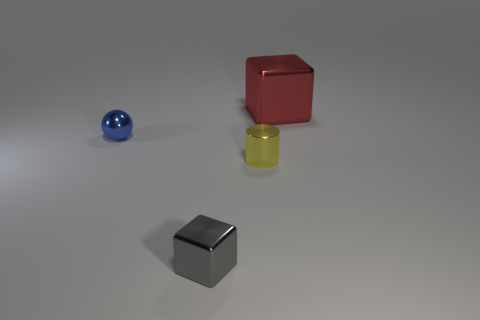Subtract all green blocks. Subtract all purple cylinders. How many blocks are left? 2 Add 1 large red metal blocks. How many objects exist? 5 Subtract all spheres. How many objects are left? 3 Add 2 gray metal blocks. How many gray metal blocks are left? 3 Add 4 small yellow metallic things. How many small yellow metallic things exist? 5 Subtract 0 brown cylinders. How many objects are left? 4 Subtract all green rubber spheres. Subtract all spheres. How many objects are left? 3 